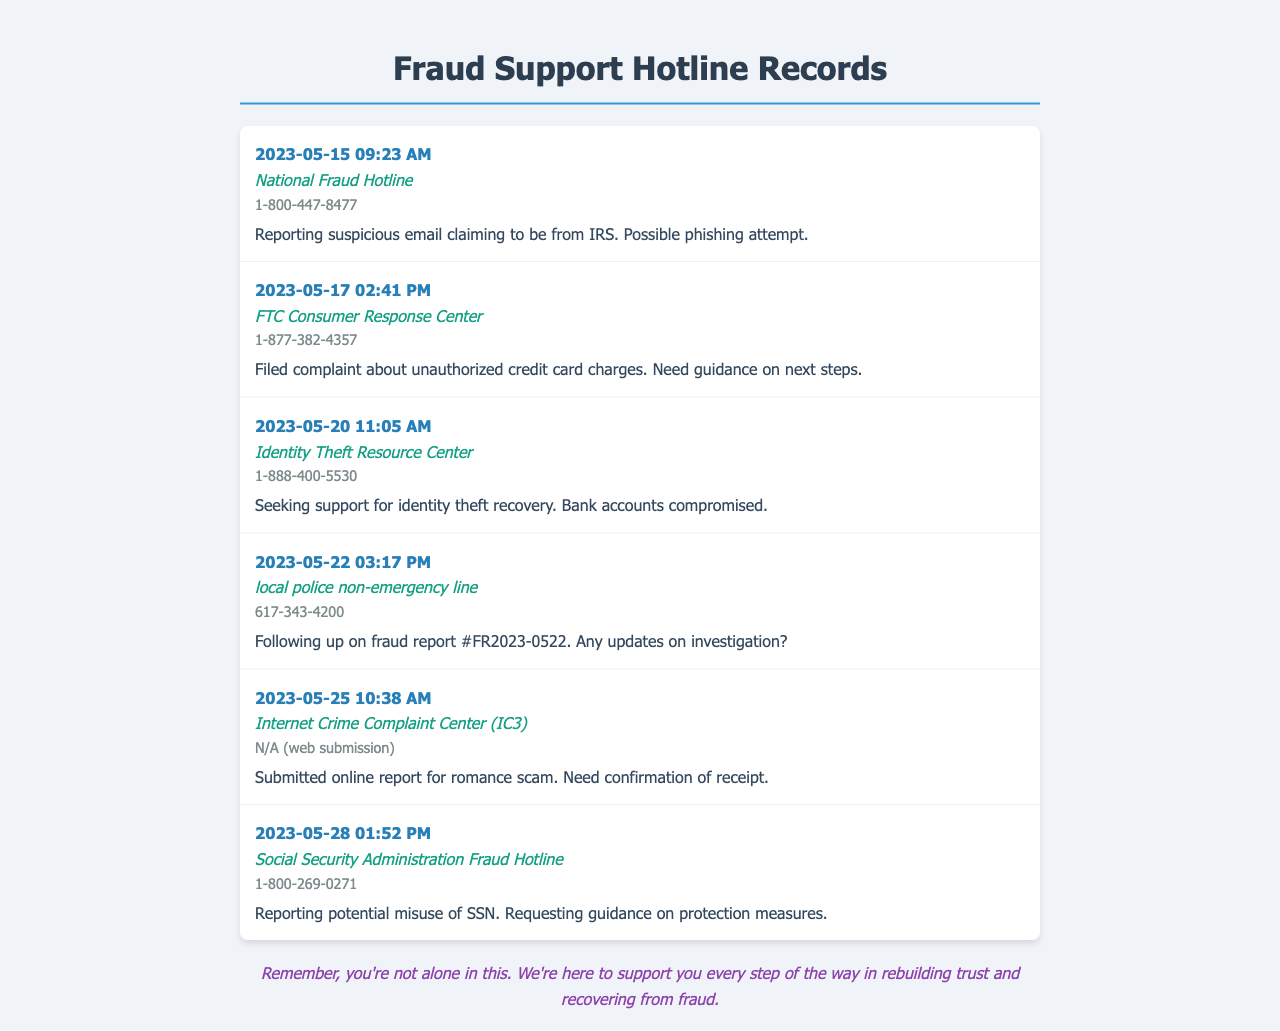What is the date of the first report? The first report is dated on May 15, 2023, as indicated in the document.
Answer: May 15, 2023 Who did the second message go to? The second message is directed to the FTC Consumer Response Center, as shown in the document.
Answer: FTC Consumer Response Center What is the phone number for the Identity Theft Resource Center? The phone number listed for the Identity Theft Resource Center is present in the document.
Answer: 1-888-400-5530 How many reports were submitted to hotlines in total? The document lists six individual reports submitted to various hotlines.
Answer: 6 Which hotline was contacted regarding a possible phishing attempt? The hotline contacted for the phishing attempt was the National Fraud Hotline, as seen in the document.
Answer: National Fraud Hotline What message type was submitted to the Internet Crime Complaint Center? The message type submitted to the IC3 was an online report, which is specified in the document.
Answer: online report What was the subject of the last report? The subject of the last report was regarding potential misuse of a Social Security Number.
Answer: potential misuse of SSN What time was the message sent to the local police non-emergency line? The message to the local police was sent at 03:17 PM, which can be found in the document.
Answer: 03:17 PM 